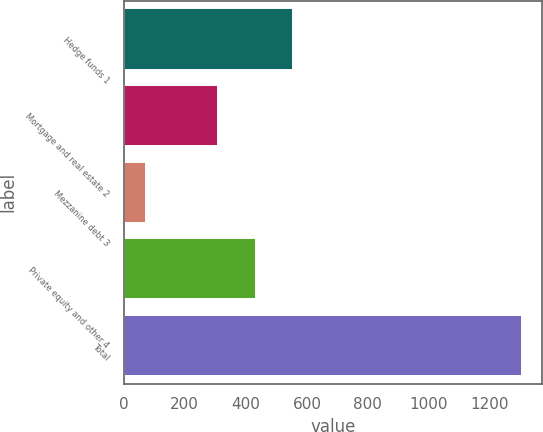Convert chart. <chart><loc_0><loc_0><loc_500><loc_500><bar_chart><fcel>Hedge funds 1<fcel>Mortgage and real estate 2<fcel>Mezzanine debt 3<fcel>Private equity and other 4<fcel>Total<nl><fcel>555.8<fcel>309<fcel>72<fcel>432.4<fcel>1306<nl></chart> 